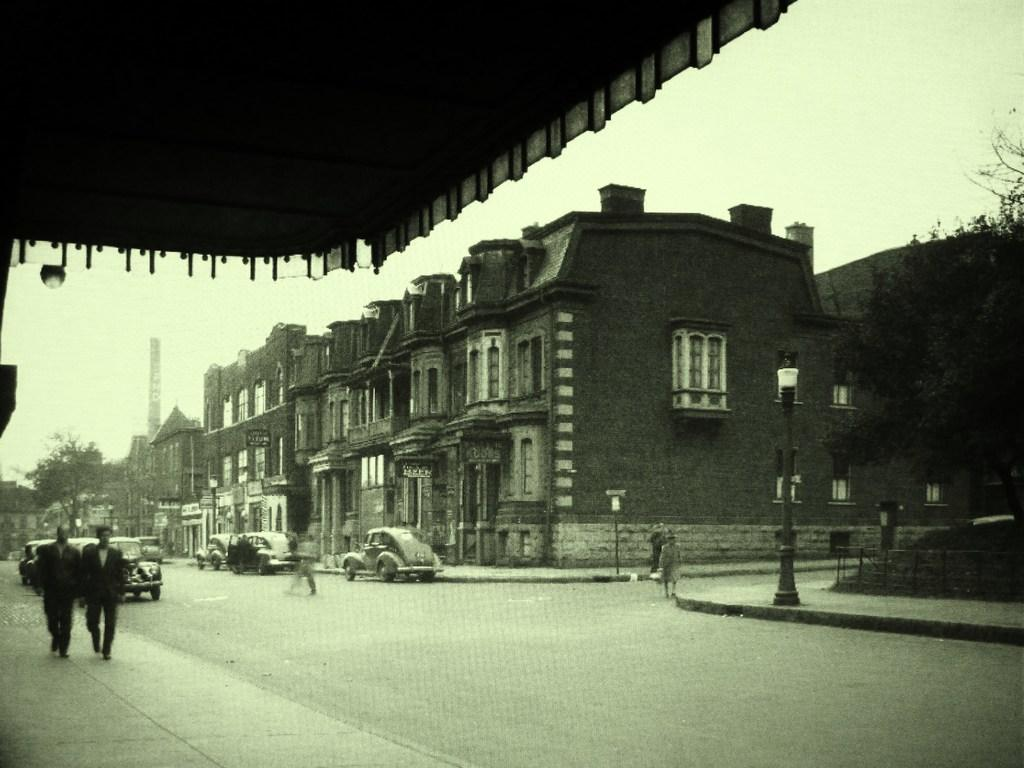What type of structures can be seen in the image? There are buildings in the image. What other natural elements are present in the image? There are trees in the image. What mode of transportation can be seen on the road in the image? There are cars on the road in the image. Are there any people visible in the image? Yes, there are people walking in the image. What type of lighting is present in the image? There are pole lights in the image. What part of the environment is visible in the image? The sky is visible in the image. Can you tell me the position of the bee in the image? There is no bee present in the image. What type of print can be seen on the people's clothing in the image? The provided facts do not mention any specific prints on the people's clothing, so we cannot answer this question. 